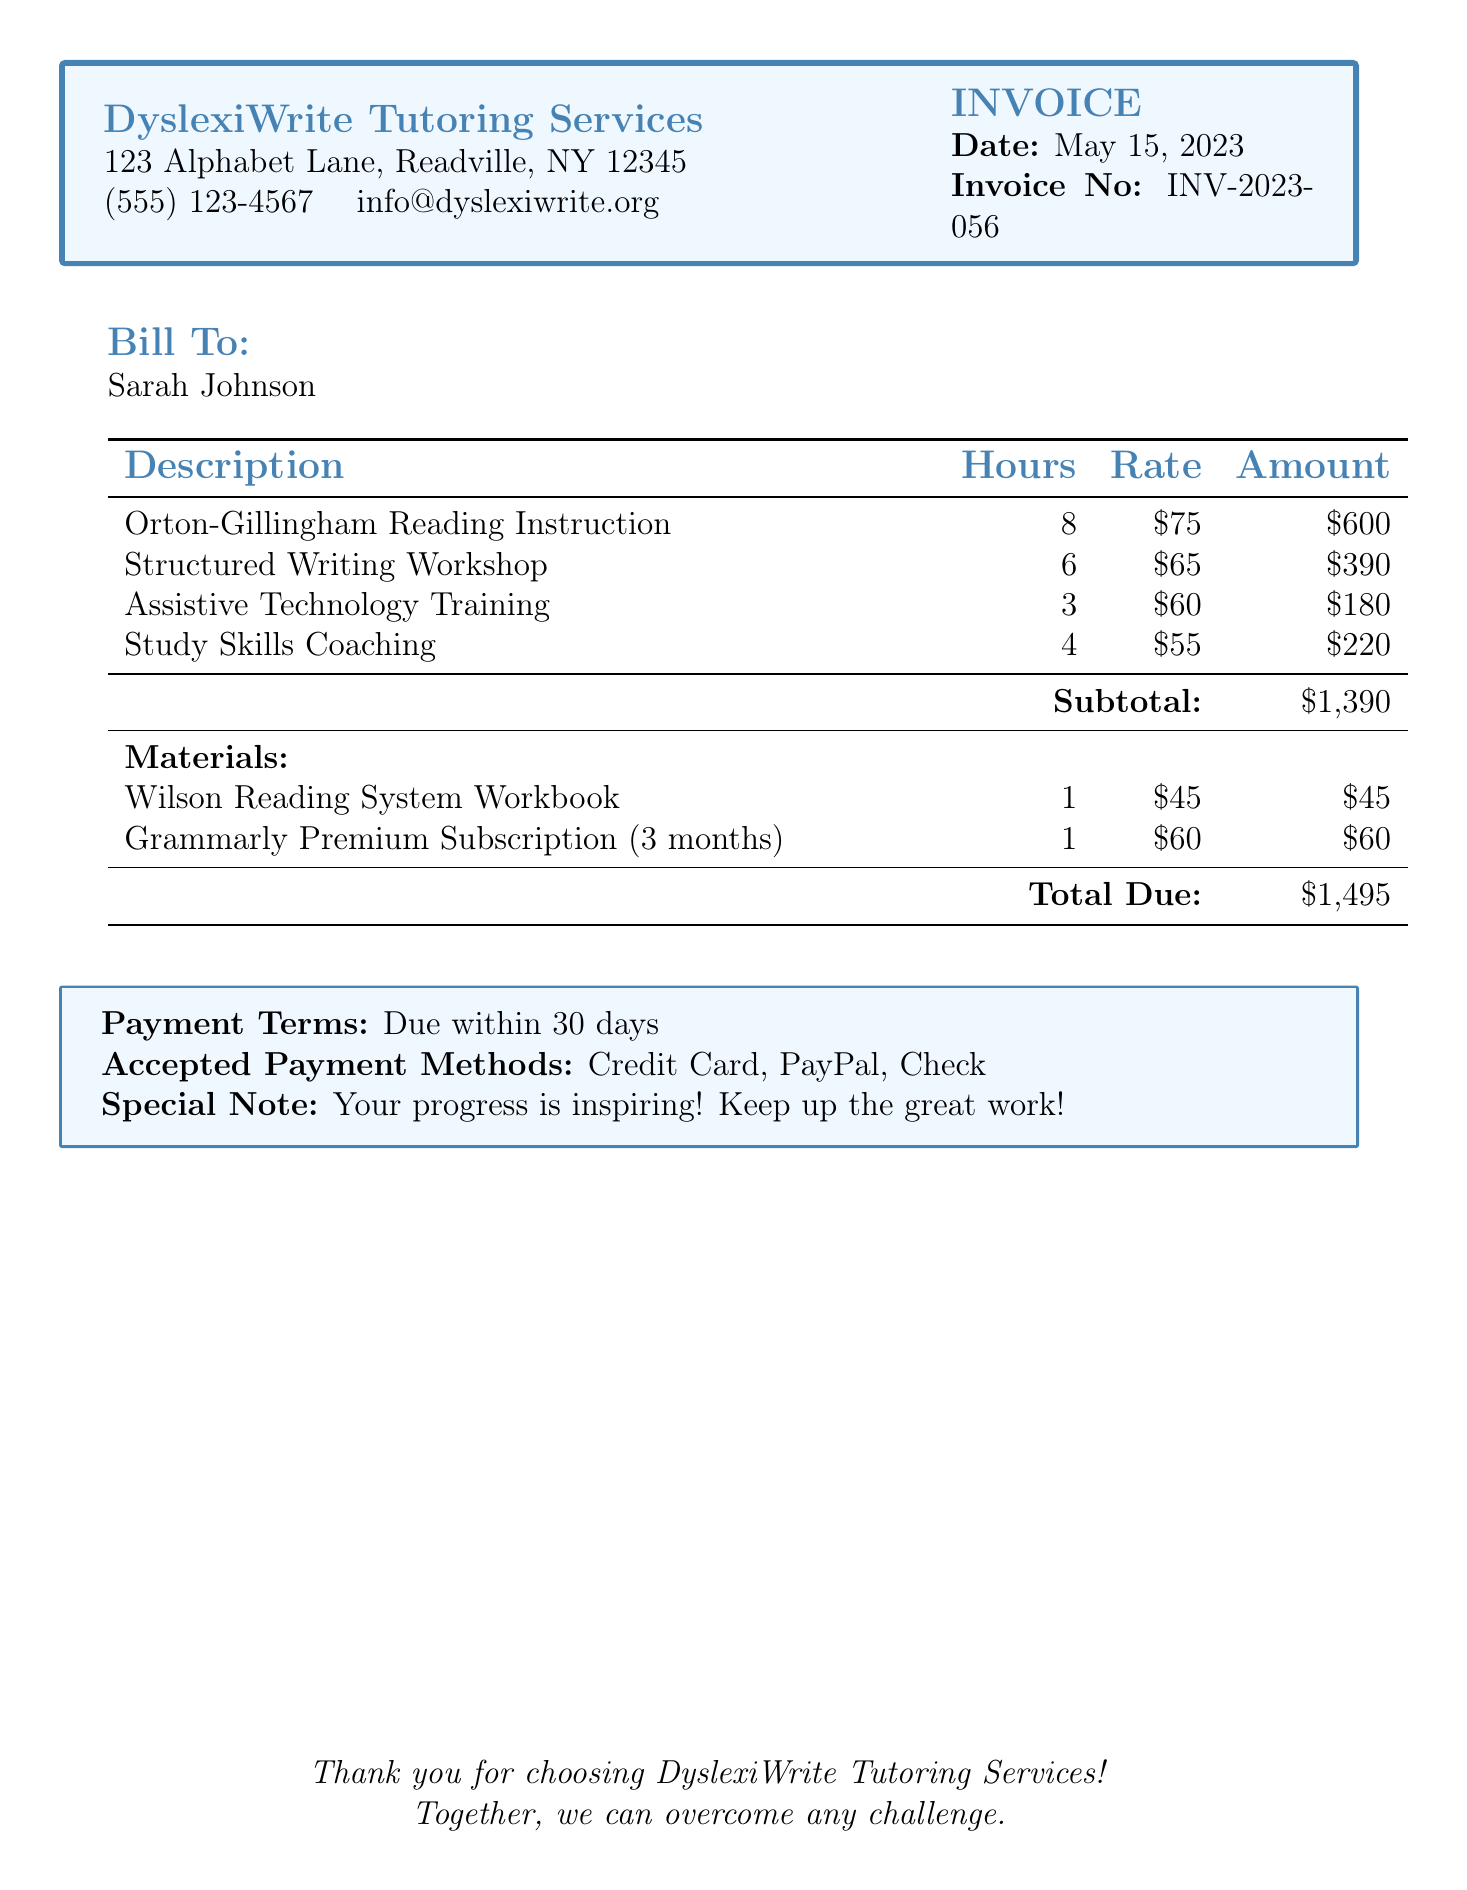What is the name of the tutoring service? The name of the tutoring service is prominently displayed at the top of the document.
Answer: DyslexiWrite Tutoring Services What is the date of the invoice? The invoice date is stated clearly near the top of the document.
Answer: May 15, 2023 What is the subtotal amount? The subtotal is calculated and shown in the table section of the document.
Answer: $1,390 How many hours were spent on the Structured Writing Workshop? The hours for each service are listed in the second column of the table.
Answer: 6 What is the rate for Assistive Technology Training? The rate is specified in the third column of the table next to the service description.
Answer: $60 Who is the bill addressed to? The "Bill To" section indicates the recipient of the invoice.
Answer: Sarah Johnson What is the total amount due? The total amount is highlighted at the bottom of the table after materials.
Answer: $1,495 How many months is the Grammarly Premium Subscription for? The details about the subscription terms are found in the materials section of the document.
Answer: 3 months What is the payment term stated in the document? The payment terms are clearly mentioned in the boxed section at the bottom.
Answer: Due within 30 days 